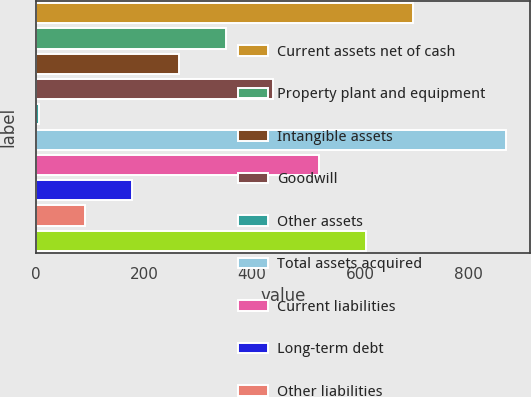<chart> <loc_0><loc_0><loc_500><loc_500><bar_chart><fcel>Current assets net of cash<fcel>Property plant and equipment<fcel>Intangible assets<fcel>Goodwill<fcel>Other assets<fcel>Total assets acquired<fcel>Current liabilities<fcel>Long-term debt<fcel>Other liabilities<fcel>Total liabilities<nl><fcel>697.8<fcel>351.4<fcel>264.8<fcel>438<fcel>5<fcel>871<fcel>524.6<fcel>178.2<fcel>91.6<fcel>611.2<nl></chart> 